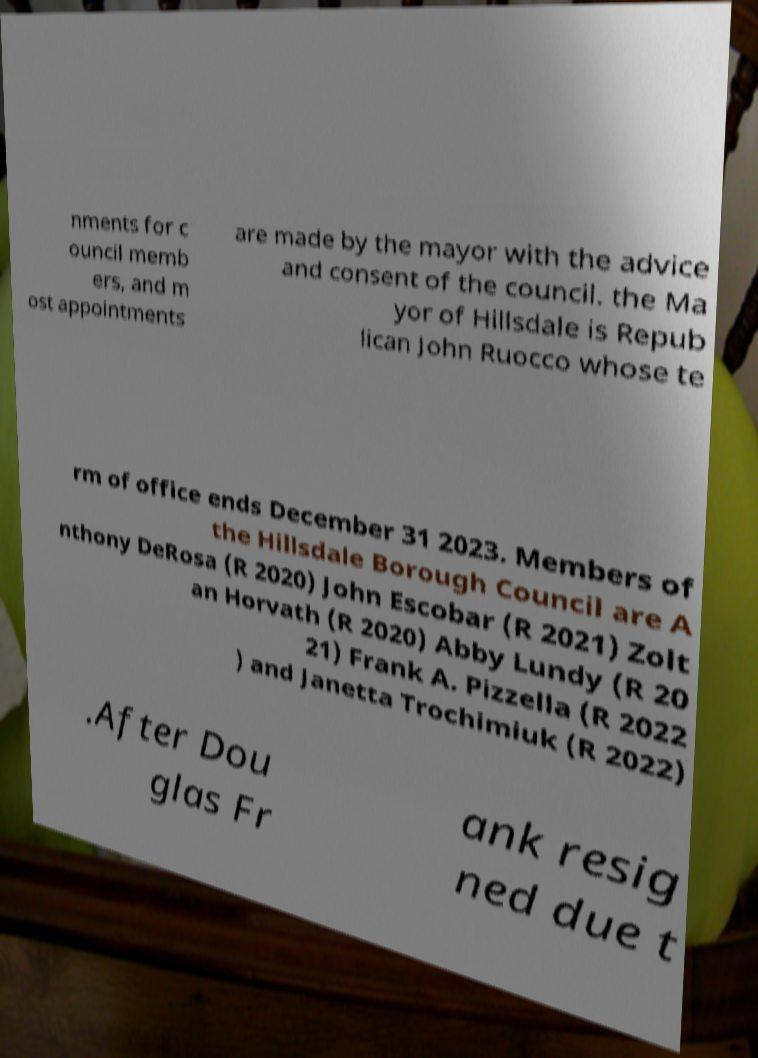For documentation purposes, I need the text within this image transcribed. Could you provide that? nments for c ouncil memb ers, and m ost appointments are made by the mayor with the advice and consent of the council. the Ma yor of Hillsdale is Repub lican John Ruocco whose te rm of office ends December 31 2023. Members of the Hillsdale Borough Council are A nthony DeRosa (R 2020) John Escobar (R 2021) Zolt an Horvath (R 2020) Abby Lundy (R 20 21) Frank A. Pizzella (R 2022 ) and Janetta Trochimiuk (R 2022) .After Dou glas Fr ank resig ned due t 